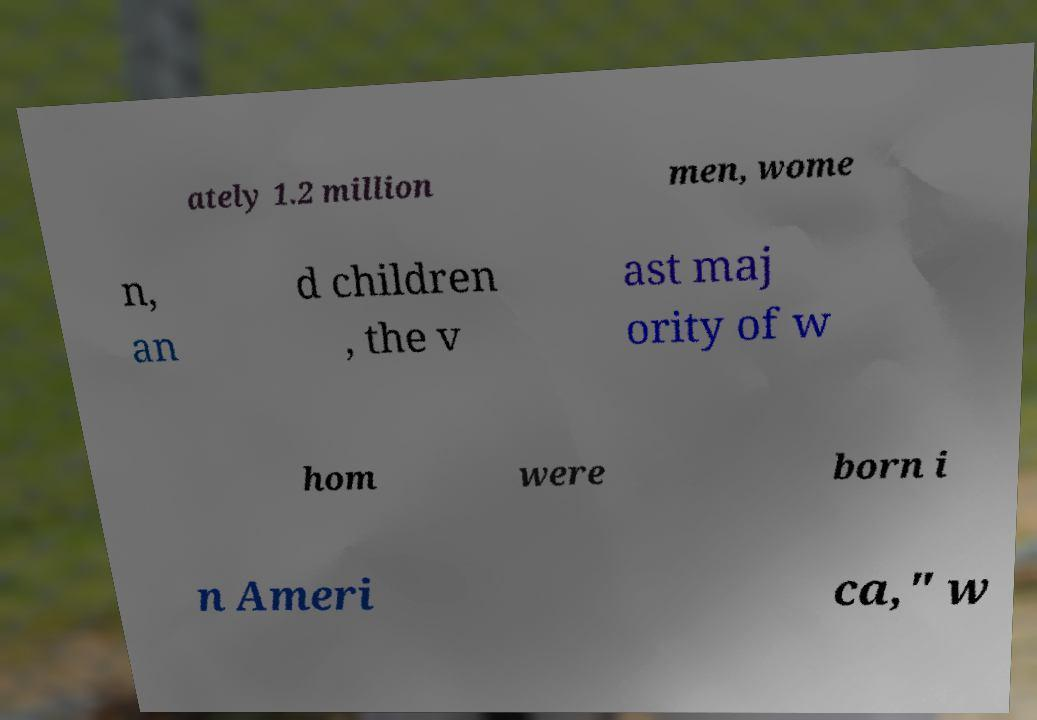What messages or text are displayed in this image? I need them in a readable, typed format. ately 1.2 million men, wome n, an d children , the v ast maj ority of w hom were born i n Ameri ca," w 